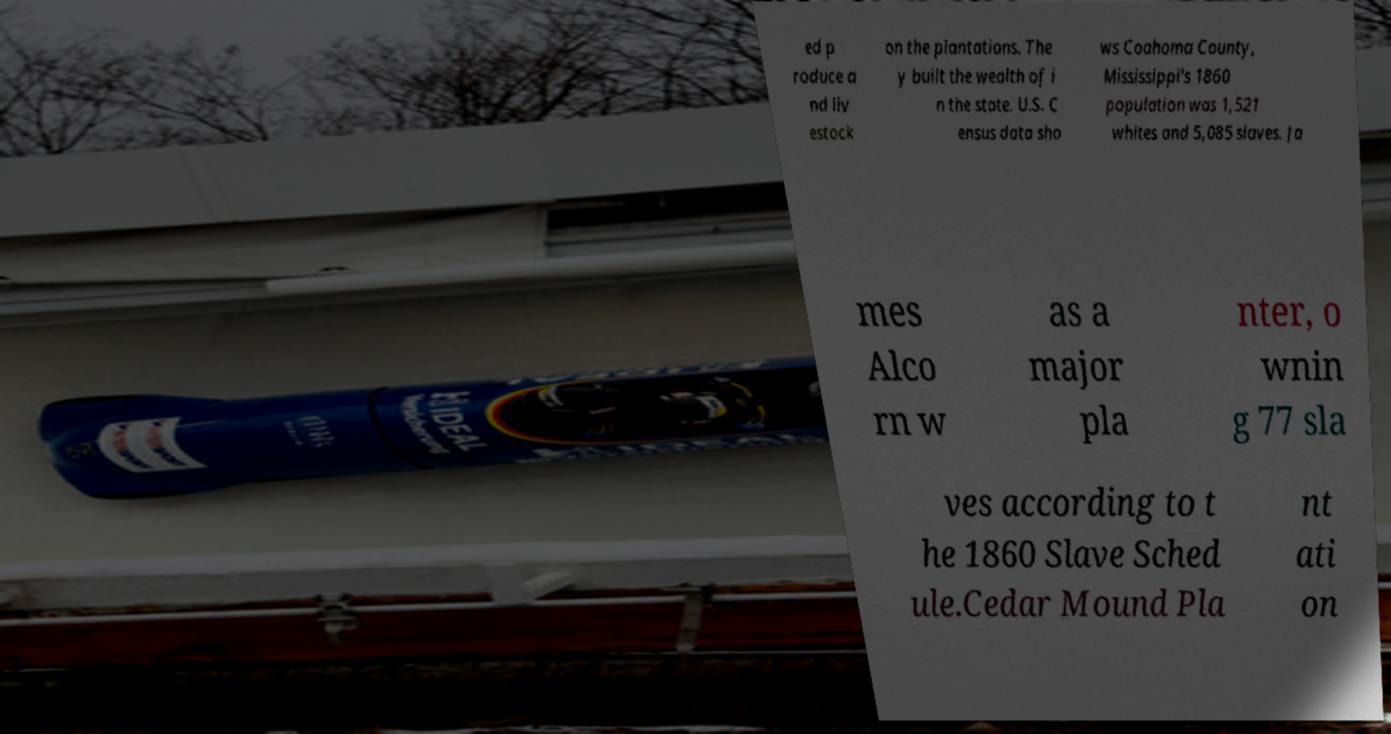Please read and relay the text visible in this image. What does it say? ed p roduce a nd liv estock on the plantations. The y built the wealth of i n the state. U.S. C ensus data sho ws Coahoma County, Mississippi's 1860 population was 1,521 whites and 5,085 slaves. Ja mes Alco rn w as a major pla nter, o wnin g 77 sla ves according to t he 1860 Slave Sched ule.Cedar Mound Pla nt ati on 